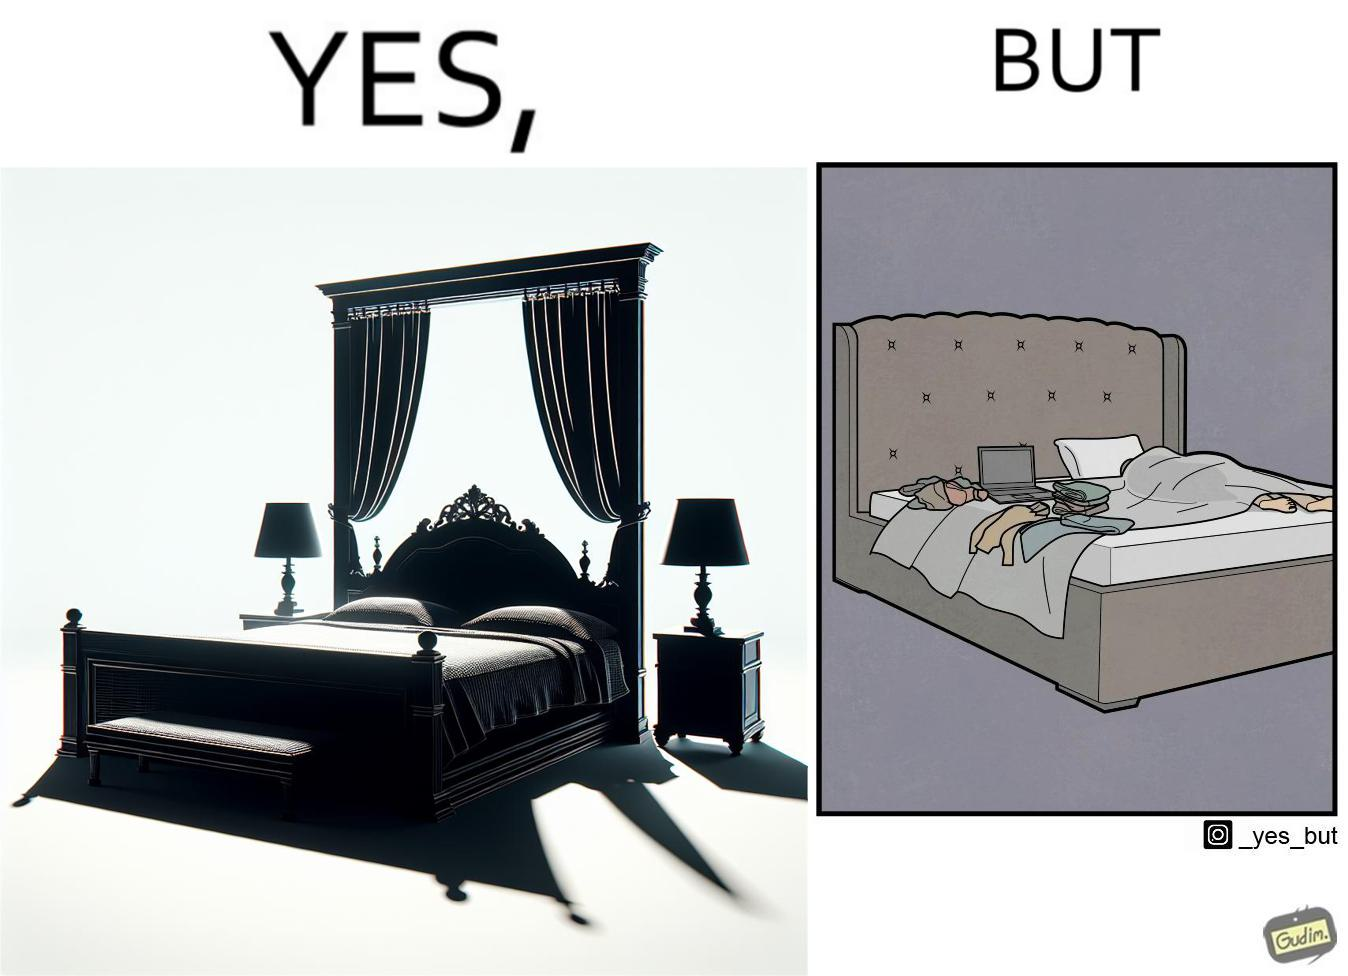Would you classify this image as satirical? Yes, this image is satirical. 